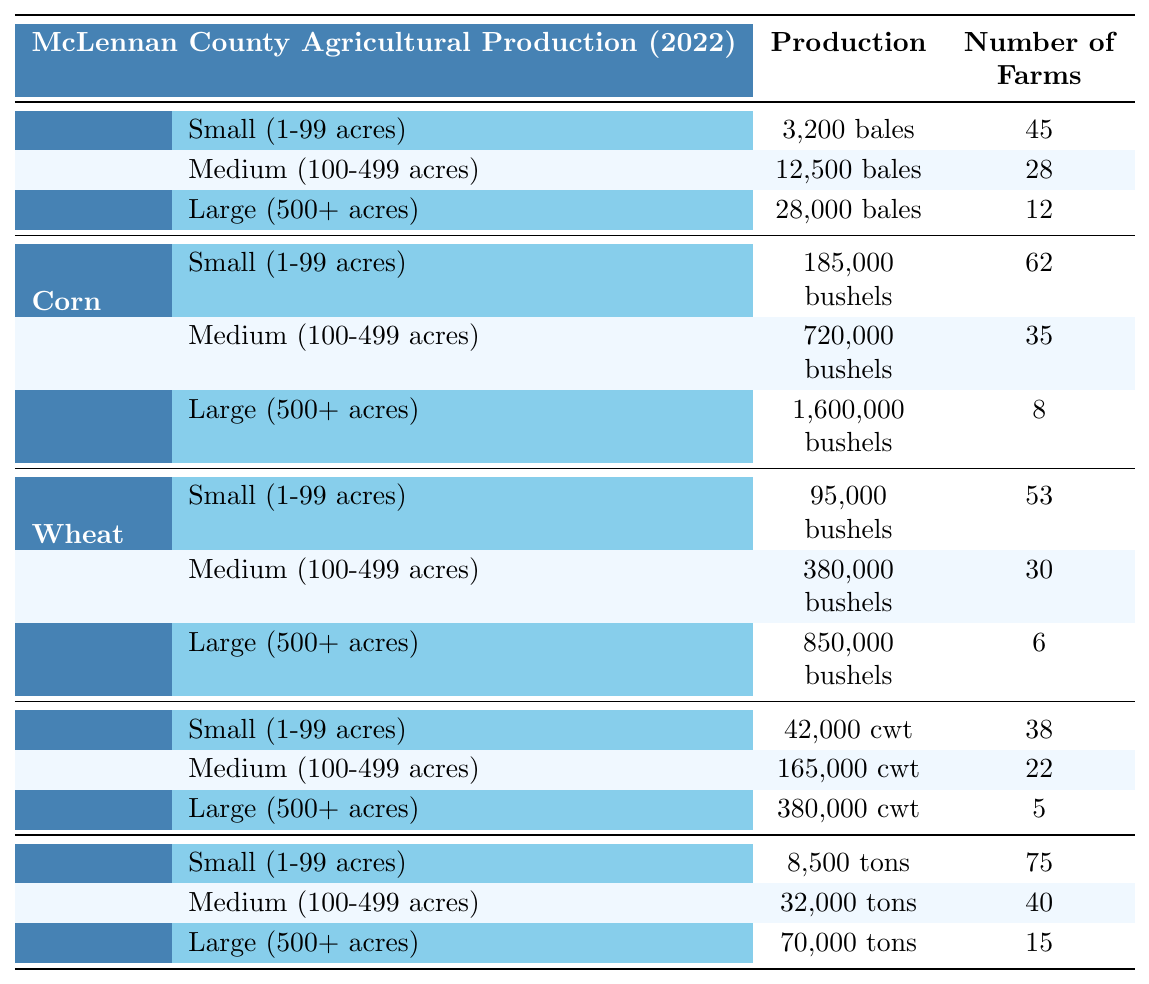What is the total production of cotton from small farms? The production of cotton from small farms is 3,200 bales.
Answer: 3,200 bales Which crop has the highest production from large farms? The crop with the highest production from large farms is corn, with 1,600,000 bushels.
Answer: Corn What is the total number of farms producing wheat? To find the total number of farms producing wheat, we add the number of farms across all sizes: 53 (small) + 30 (medium) + 6 (large) = 89.
Answer: 89 What is the total production of hay from medium and large farms combined? The production of hay from medium farms is 32,000 tons, and from large farms, it is 70,000 tons. Summing these gives us 32,000 + 70,000 = 102,000 tons.
Answer: 102,000 tons Is there a larger number of farms producing sorghum than producing wheat? There are 38 farms producing sorghum (small) + 22 (medium) + 5 (large) = 65 farms producing sorghum, while wheat has 53 (small) + 30 (medium) + 6 (large) = 89 farms. Since 65 < 89, the answer is no.
Answer: No What is the average production of corn from small, medium, and large farms? The production values for corn are 185,000 (small), 720,000 (medium), and 1,600,000 (large). The average production is (185,000 + 720,000 + 1,600,000) / 3 = 1,505,000 / 3 = 501,666.67.
Answer: 501,666.67 How many more farms produce hay than produce cotton? First, count the number of farms for hay: 75 (small) + 40 (medium) + 15 (large) = 130. Then count for cotton: 45 (small) + 28 (medium) + 12 (large) = 85. The difference is 130 - 85 = 45.
Answer: 45 What proportion of corn farms are large-sized farms? The number of large-sized corn farms is 8, while the total number of corn farms is 62 (small) + 35 (medium) + 8 (large) = 105. The proportion is 8 / 105 = 0.07619 or approximately 7.62%.
Answer: 7.62% Which crop's small farms have the highest production per farm? We calculate the production per farm for each crop's small size. For cotton: 3,200 bales / 45 farms = 71.11 bales per farm. For corn: 185,000 bushels / 62 farms = 2,987.10 bushels per farm. For wheat: 95,000 bushels / 53 farms = 1,792.45 bushels per farm. For sorghum: 42,000 cwt / 38 farms = 1,105.26 cwt per farm. For hay: 8,500 tons / 75 farms = 113.33 tons per farm. The highest is for corn, with approximately 2,987.10 bushels per farm.
Answer: Corn What is the total production of small farms across all crops? Sum the production from each small farm category: Cotton: 3,200 bales, Corn: 185,000 bushels, Wheat: 95,000 bushels, Sorghum: 42,000 cwt, Hay: 8,500 tons. Total = 3,200 + 185,000 + 95,000 + 42,000 + 8,500 = 333,700.
Answer: 333,700 